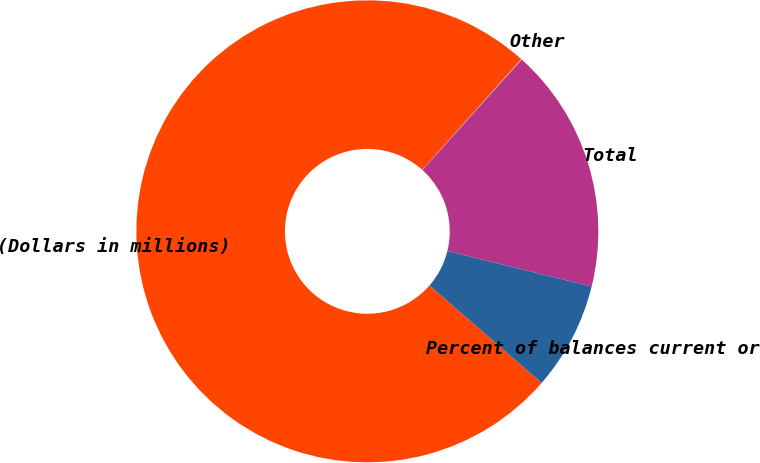Convert chart. <chart><loc_0><loc_0><loc_500><loc_500><pie_chart><fcel>(Dollars in millions)<fcel>Other<fcel>Total<fcel>Percent of balances current or<nl><fcel>75.22%<fcel>0.04%<fcel>17.19%<fcel>7.56%<nl></chart> 